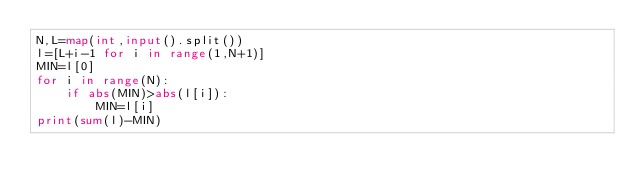Convert code to text. <code><loc_0><loc_0><loc_500><loc_500><_Python_>N,L=map(int,input().split())
l=[L+i-1 for i in range(1,N+1)]
MIN=l[0]
for i in range(N):
    if abs(MIN)>abs(l[i]):
        MIN=l[i]
print(sum(l)-MIN)</code> 